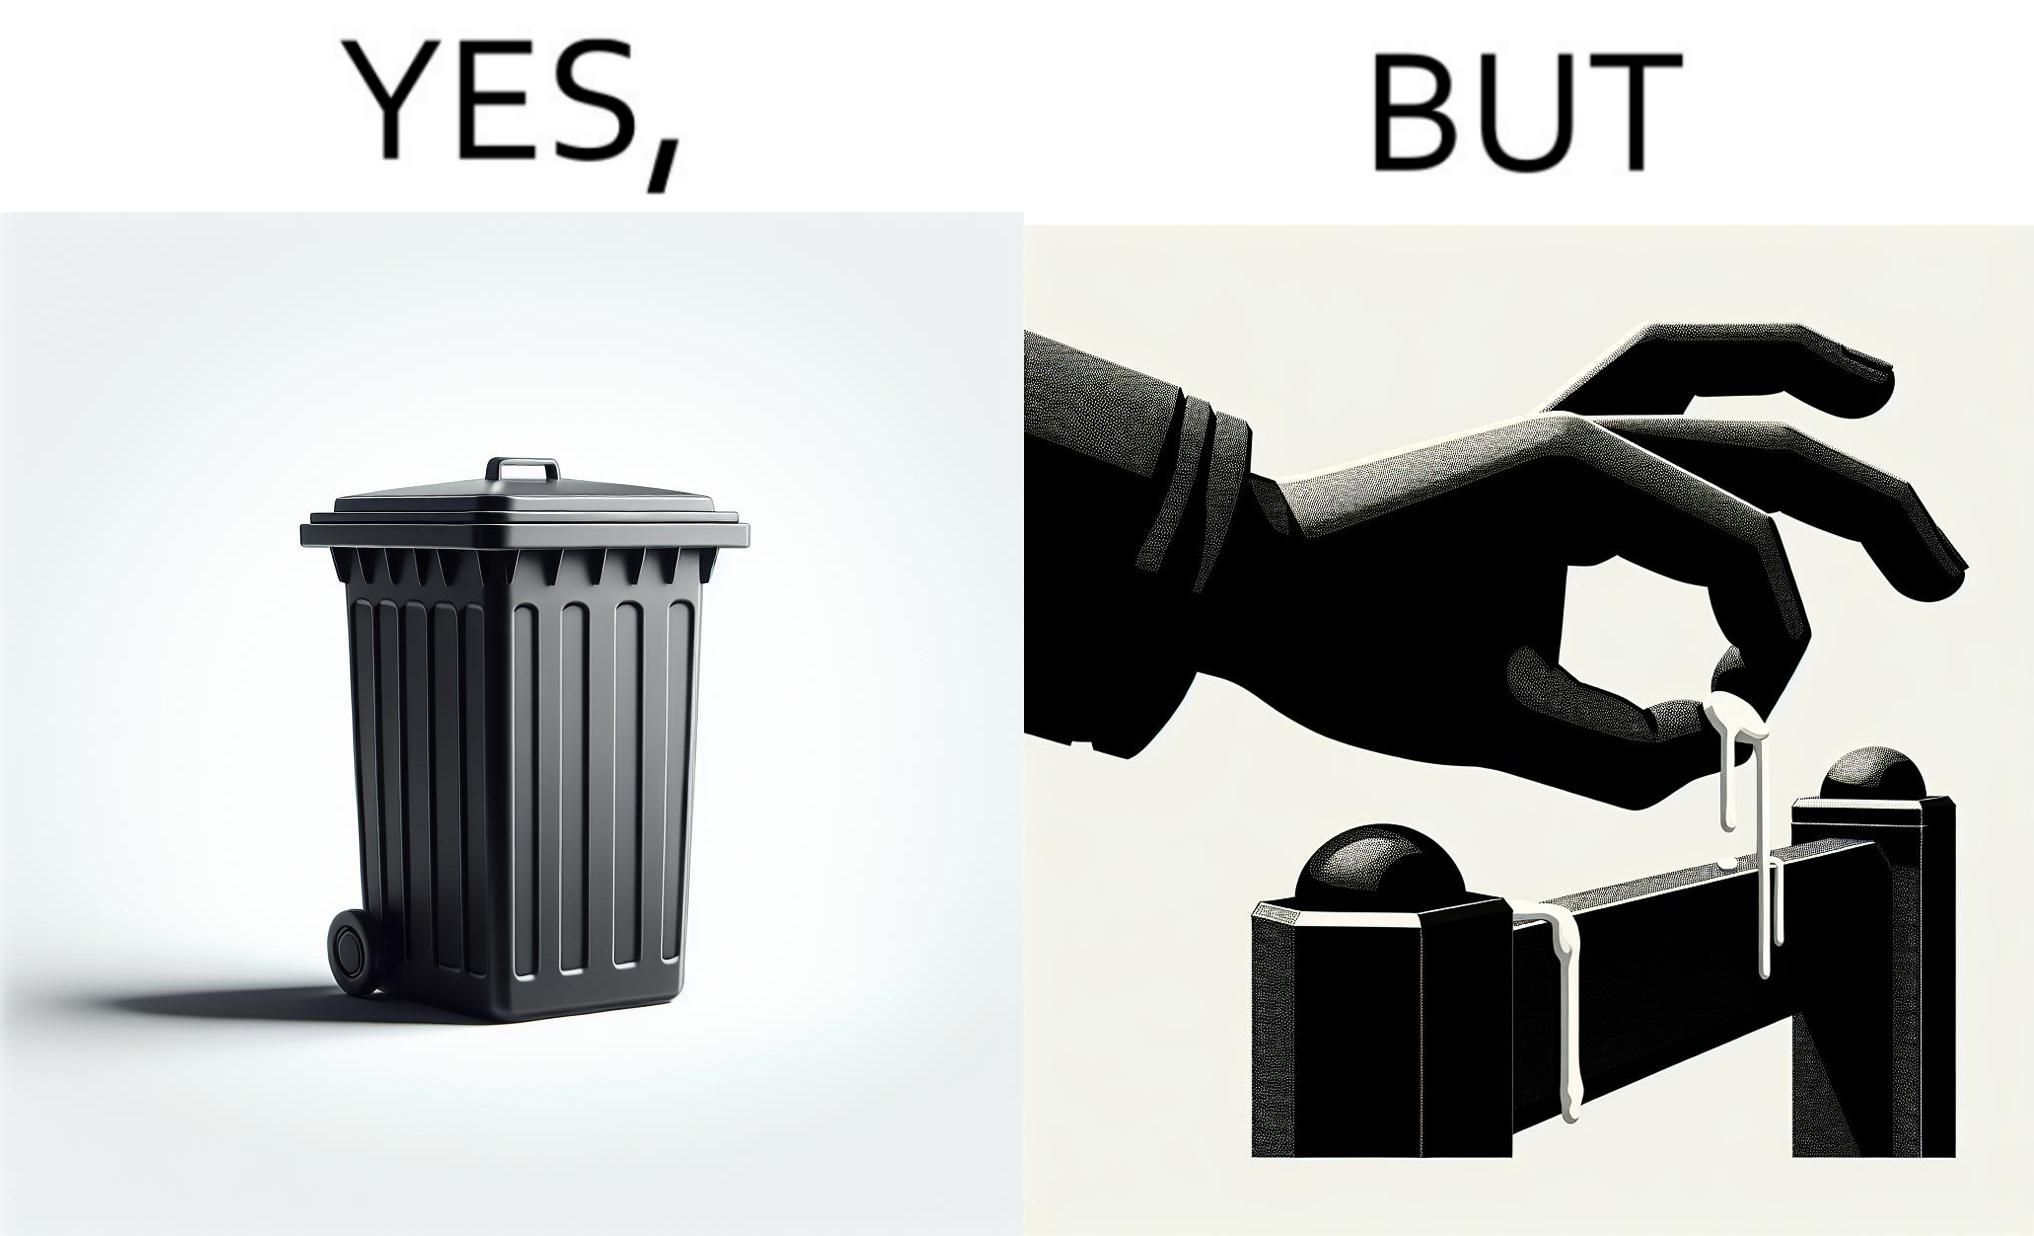Is this image satirical or non-satirical? Yes, this image is satirical. 